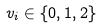<formula> <loc_0><loc_0><loc_500><loc_500>v _ { i } \in \{ 0 , 1 , 2 \}</formula> 